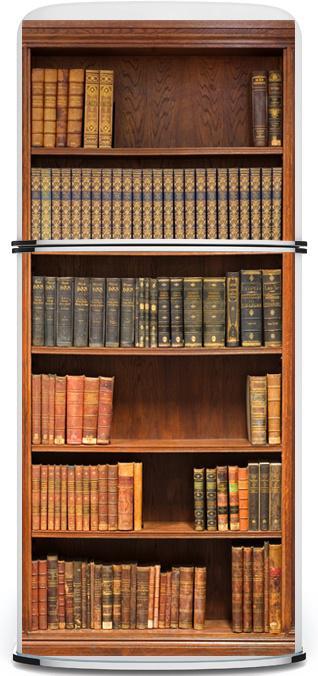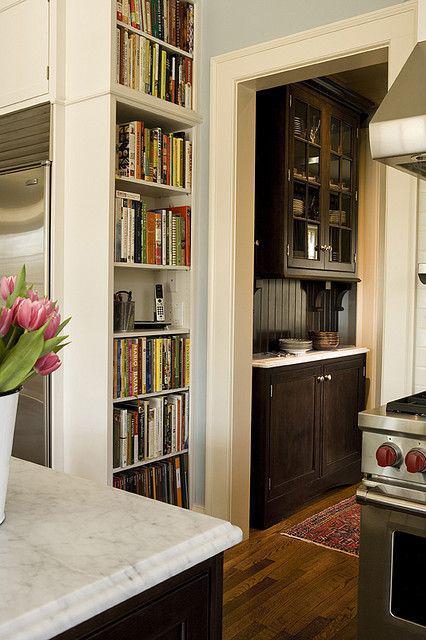The first image is the image on the left, the second image is the image on the right. Given the left and right images, does the statement "At least one image features a bookcase with reddish-brown panels at the bottom and eight vertical shelves." hold true? Answer yes or no. No. The first image is the image on the left, the second image is the image on the right. For the images shown, is this caption "An object is next to one of the bookcases." true? Answer yes or no. No. 